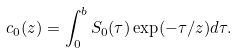<formula> <loc_0><loc_0><loc_500><loc_500>c _ { 0 } ( z ) = \int _ { 0 } ^ { b } S _ { 0 } ( \tau ) \exp ( - \tau / z ) d \tau .</formula> 